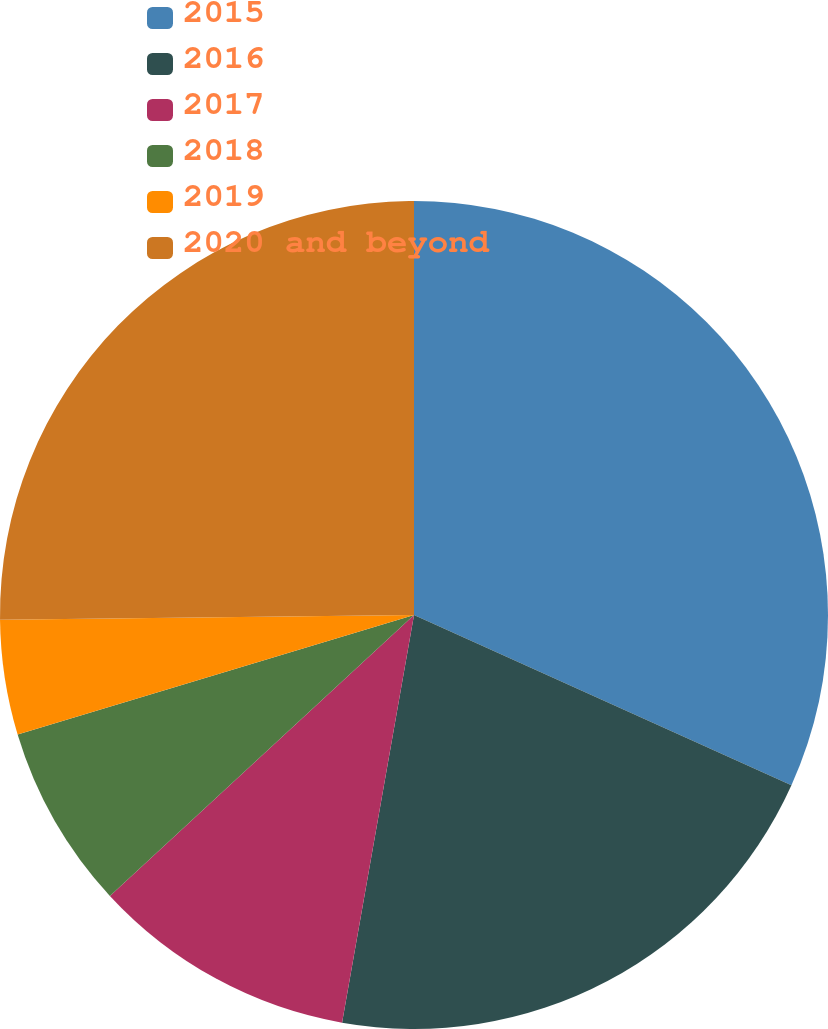Convert chart to OTSL. <chart><loc_0><loc_0><loc_500><loc_500><pie_chart><fcel>2015<fcel>2016<fcel>2017<fcel>2018<fcel>2019<fcel>2020 and beyond<nl><fcel>31.74%<fcel>21.04%<fcel>10.35%<fcel>7.21%<fcel>4.48%<fcel>25.18%<nl></chart> 